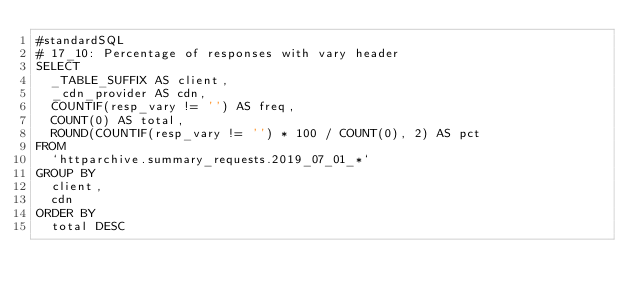<code> <loc_0><loc_0><loc_500><loc_500><_SQL_>#standardSQL
# 17_10: Percentage of responses with vary header
SELECT
  _TABLE_SUFFIX AS client,
  _cdn_provider AS cdn,
  COUNTIF(resp_vary != '') AS freq,
  COUNT(0) AS total,
  ROUND(COUNTIF(resp_vary != '') * 100 / COUNT(0), 2) AS pct
FROM
  `httparchive.summary_requests.2019_07_01_*`
GROUP BY
  client,
  cdn
ORDER BY
  total DESC</code> 